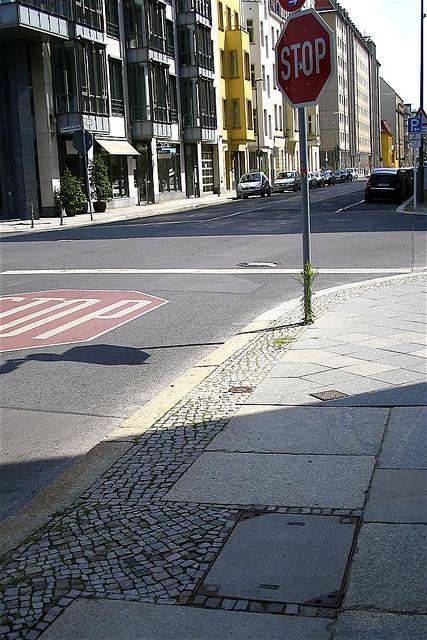How many stop signs are in the photo?
Give a very brief answer. 2. How many orange cones are there?
Give a very brief answer. 0. 